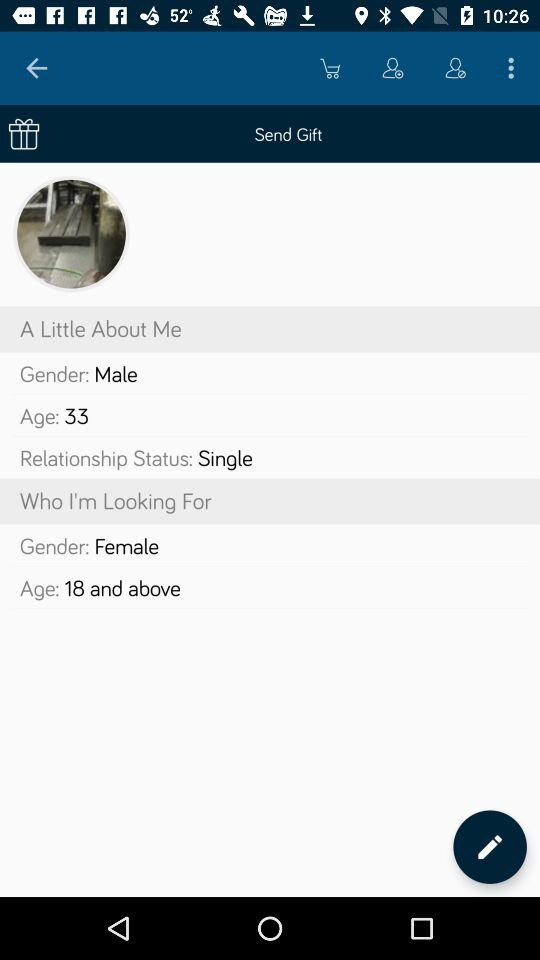What is the given age of the user? The given age of the user is 33. 